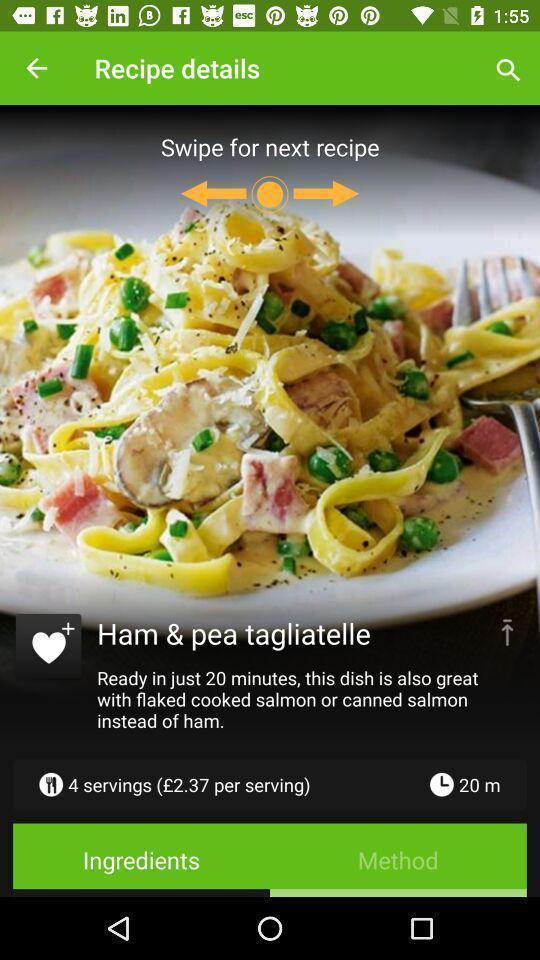Summarize the main components in this picture. Screen displaying page of an cooking application. 